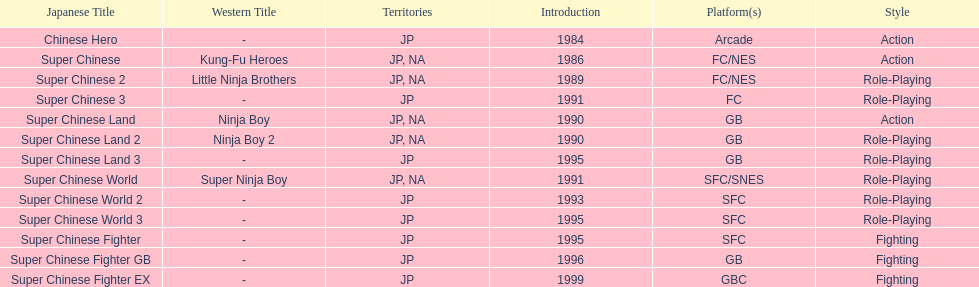What are the total of super chinese games released? 13. 